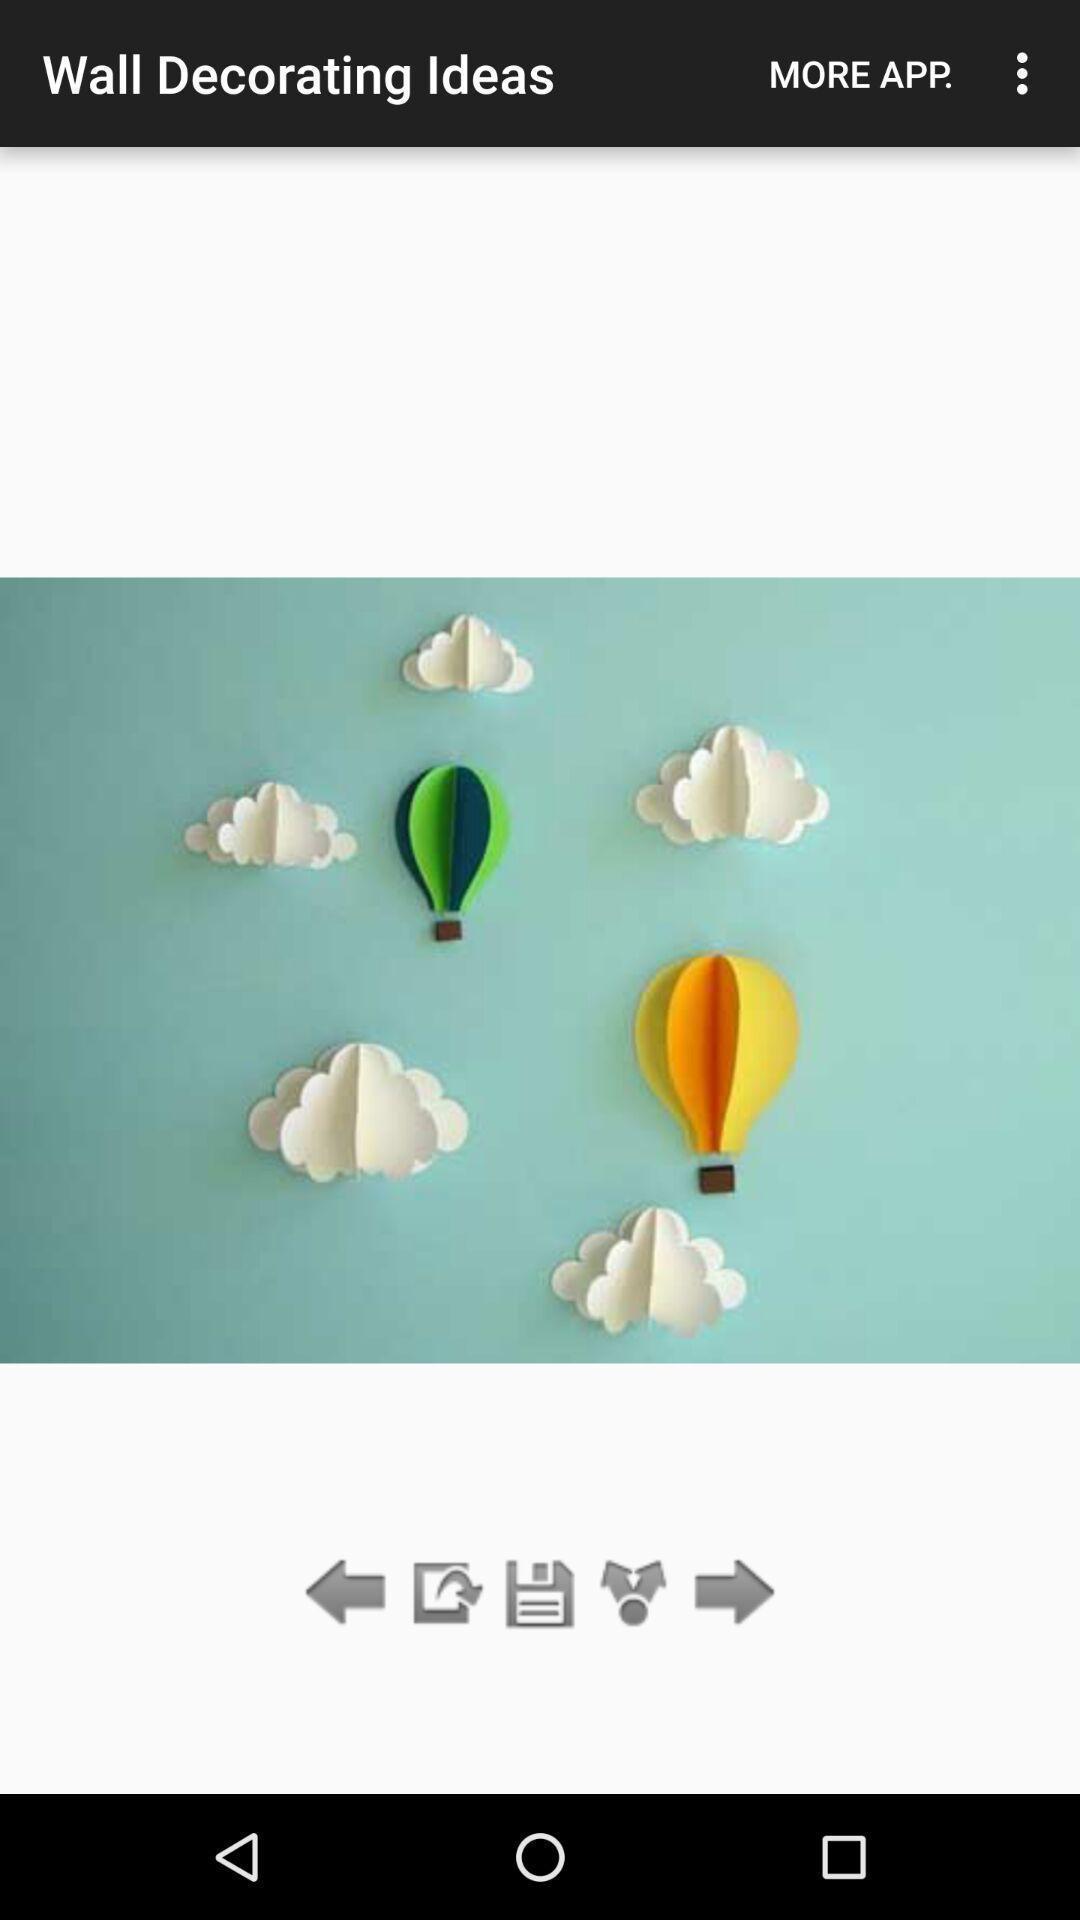Describe this image in words. Screen showing a picture of wall decorated on an app. 